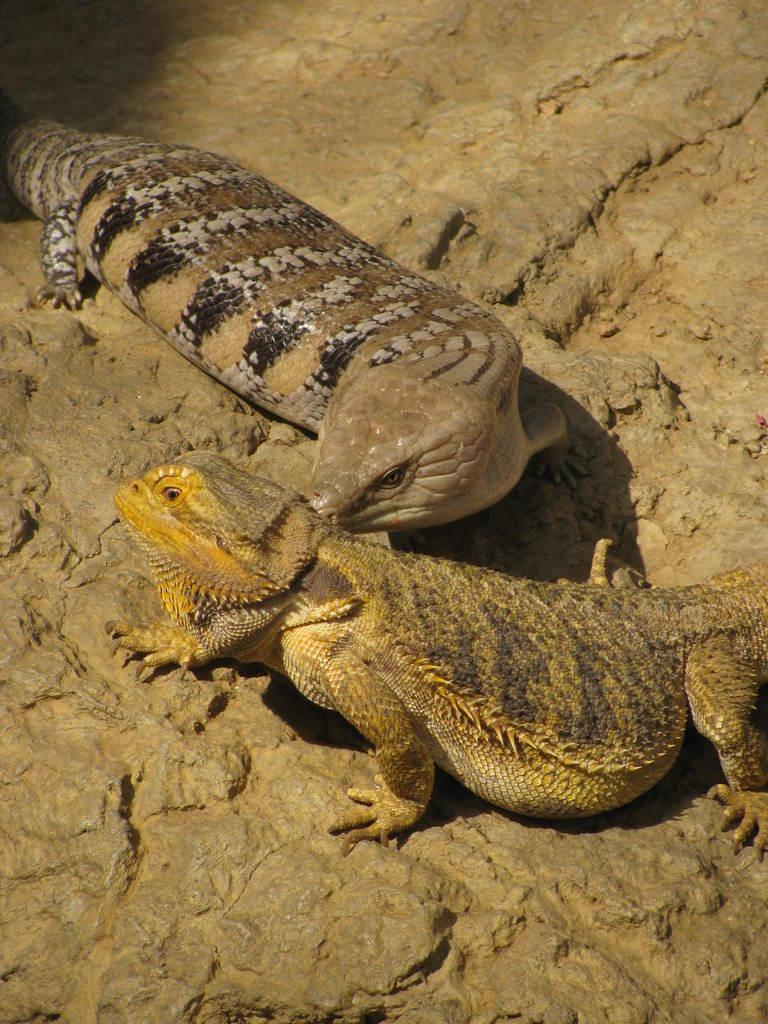How many reptiles are present in the image? There are two reptiles in the image. What is the surface on which the reptiles are located? The reptiles are on a brown color surface. What colors can be seen on the reptiles? The reptiles have cream, brown, and black colors. What type of chess pieces can be seen in the image? There are no chess pieces present in the image; it features two reptiles on a brown surface. 